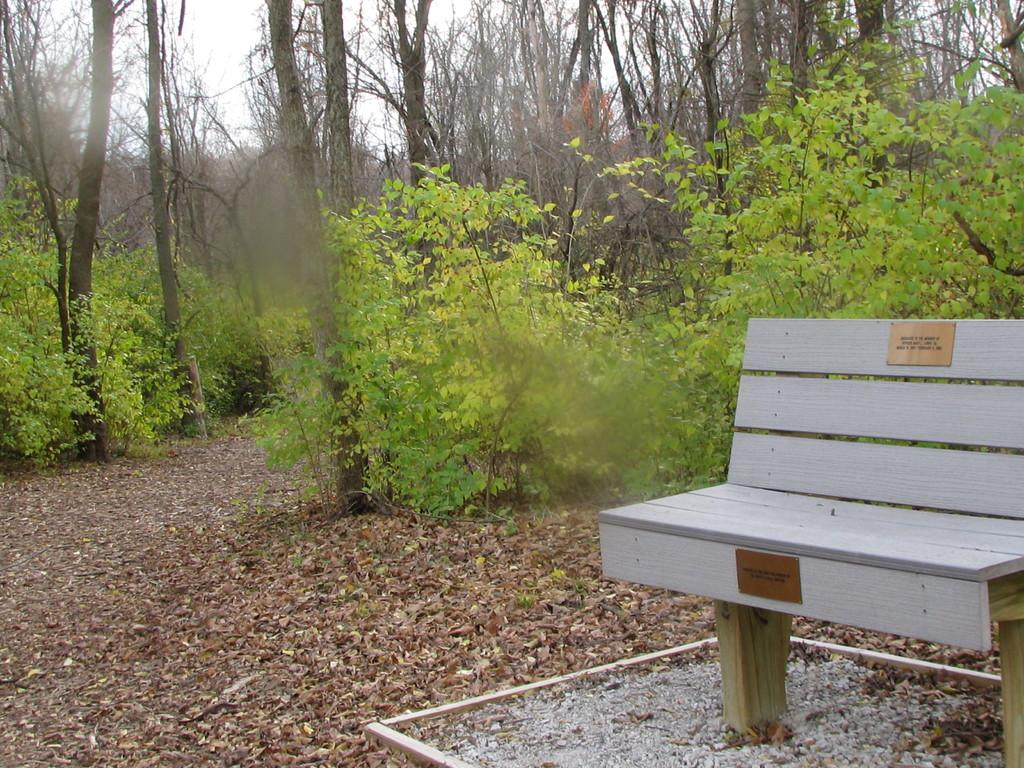What type of seating is present in the image? There is a bench in the image. What can be seen in the background of the image? Many trees are visible in the image. What is the color of the sky in the image? The sky is white in the image. Where is the cow sitting on the bench in the image? There is no cow present in the image, so it cannot be sitting on the bench. 